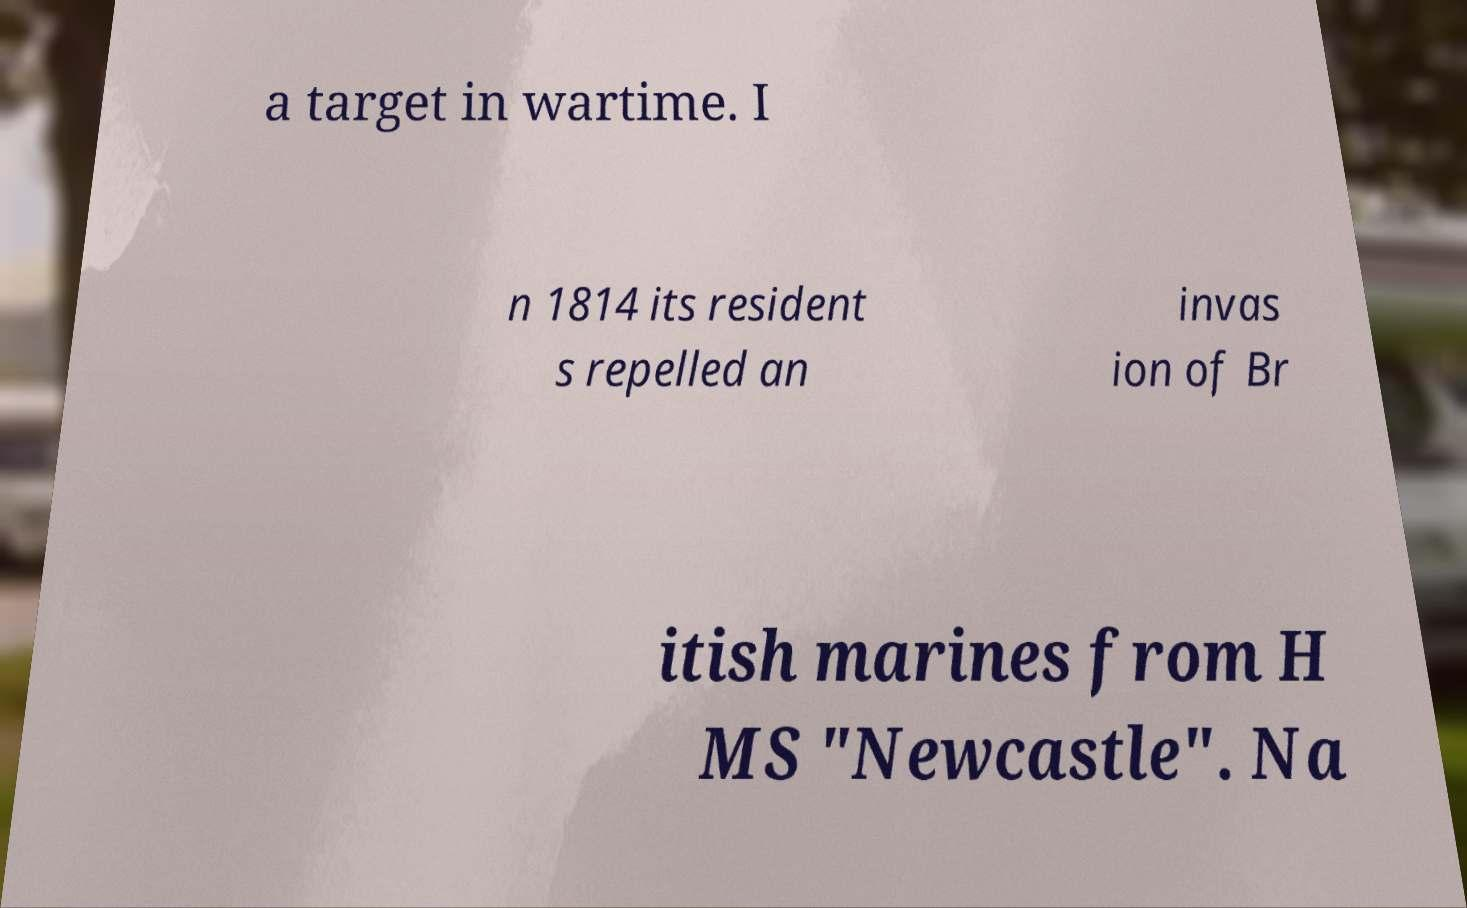Could you extract and type out the text from this image? a target in wartime. I n 1814 its resident s repelled an invas ion of Br itish marines from H MS "Newcastle". Na 